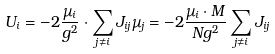Convert formula to latex. <formula><loc_0><loc_0><loc_500><loc_500>U _ { i } = - 2 \frac { \mu _ { i } } { g ^ { 2 } } \cdot \sum _ { j \neq i } J _ { i j } \mu _ { j } = - 2 \frac { \mu _ { i } \cdot M } { N g ^ { 2 } } \sum _ { j \neq i } J _ { i j }</formula> 